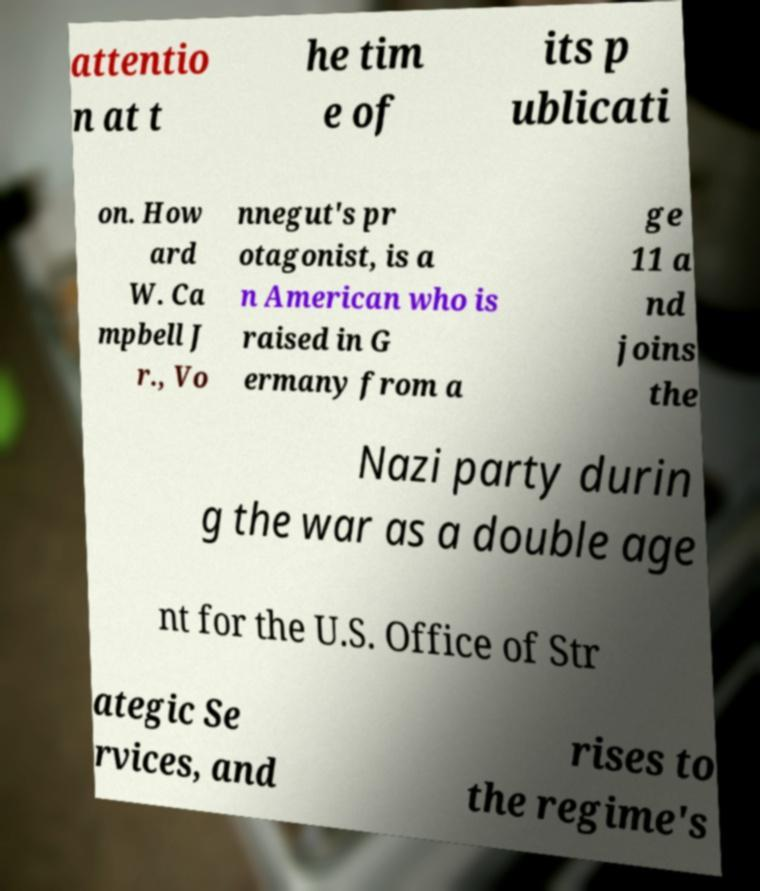There's text embedded in this image that I need extracted. Can you transcribe it verbatim? attentio n at t he tim e of its p ublicati on. How ard W. Ca mpbell J r., Vo nnegut's pr otagonist, is a n American who is raised in G ermany from a ge 11 a nd joins the Nazi party durin g the war as a double age nt for the U.S. Office of Str ategic Se rvices, and rises to the regime's 